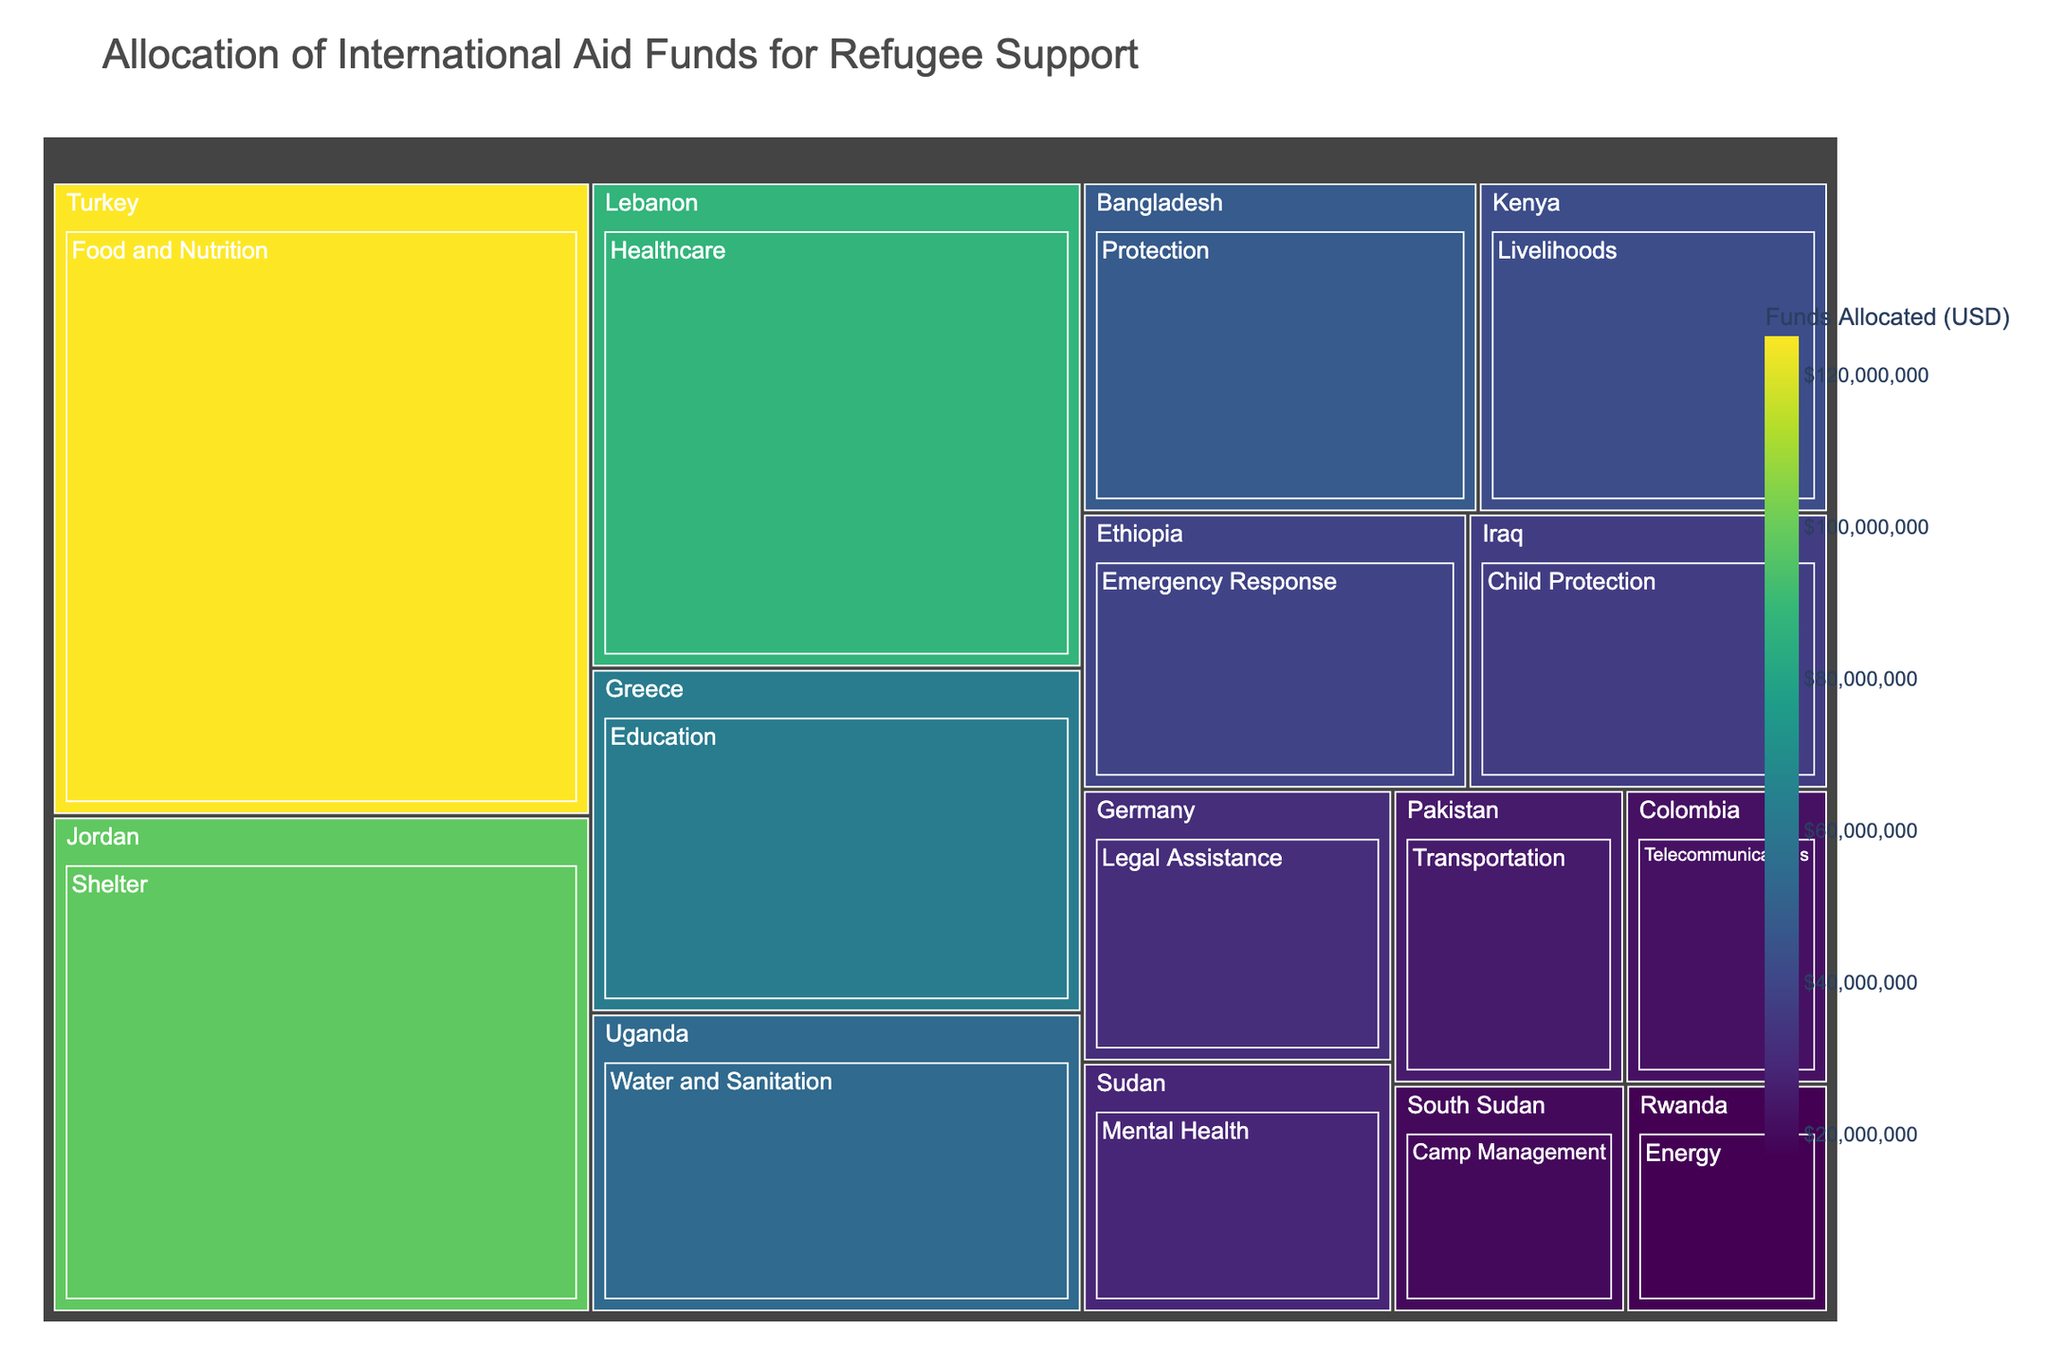What is the title of the treemap? The title is usually located at the top of the treemap and clearly indicates what the visualization represents.
Answer: Allocation of International Aid Funds for Refugee Support Which country received the highest allocation of funds, and for which sector? Look for the largest block in the treemap and check its labeling for the country and sector it represents.
Answer: Turkey, Food and Nutrition How many countries are represented in the treemap? Count the distinct labels representing countries within the hierarchical structure of the treemap.
Answer: 15 By how much does the funds allocated to Shelter in Jordan exceed the funds allocated to Healthcare in Lebanon? Subtract the allocated funds for Healthcare in Lebanon from the allocated funds for Shelter in Jordan. 98,000,000 - 87,500,000 = 10,500,000
Answer: 10,500,000 USD What is the total amount of funds allocated across all countries? Sum the funds for each country as labeled on the treemap. 125,000,000 + 98,000,000 + 87,500,000 + 62,000,000 + 54,000,000 + 48,000,000 + 42,500,000 + 39,000,000 + 36,500,000 + 31,000,000 + 28,500,000 + 25,000,000 + 22,000,000 + 19,500,000 + 17,000,000
Answer: 735,000,000 USD Which sector received the least amount of funds, and in which country? Look for the smallest block in the treemap and read the labeling to identify the country and sector.
Answer: Energy, Rwanda How does the amount allocated to Water and Sanitation in Uganda compare to that allocated to Emergency Response in Ethiopia? Compare the two amounts and determine if one is greater or smaller. 54,000,000 (Uganda) vs 39,000,000 (Ethiopia)
Answer: Uganda received more funds than Ethiopia What is the average amount of funds allocated per sector across all countries? Find the total funds allocated and divide by the number of sectors. 735,000,000 / 15
Answer: 49,000,000 USD What color is used to represent the highest funding level in the treemap? The color representing the highest funding can be found in the color legend corresponding to the largest block.
Answer: Dark purple Which sector in Greece received funds, and how does its funding compare to that of Livelihoods in Kenya? Identify the sector in Greece and compare its funding to that of Kenya’s Livelihoods. 62,000,000 (Greece, Education) vs 42,500,000 (Kenya, Livelihoods)
Answer: Education in Greece received more funds than Livelihoods in Kenya 